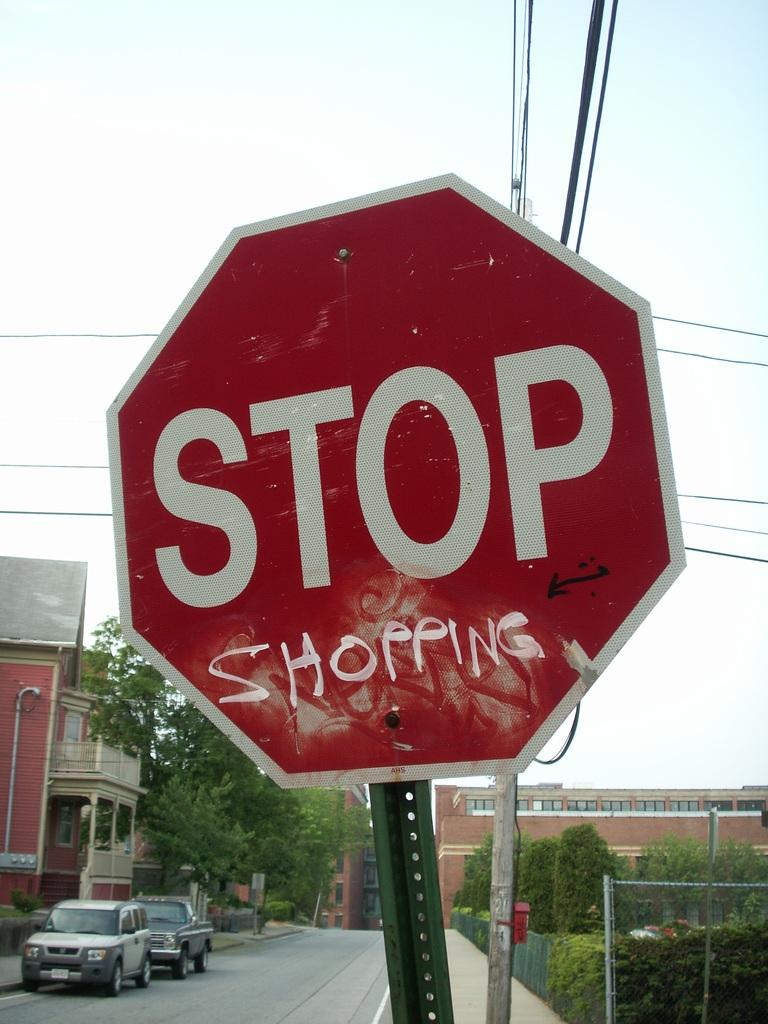Provide a one-sentence caption for the provided image. Someone has graffitied the word shopping on this road sign. 